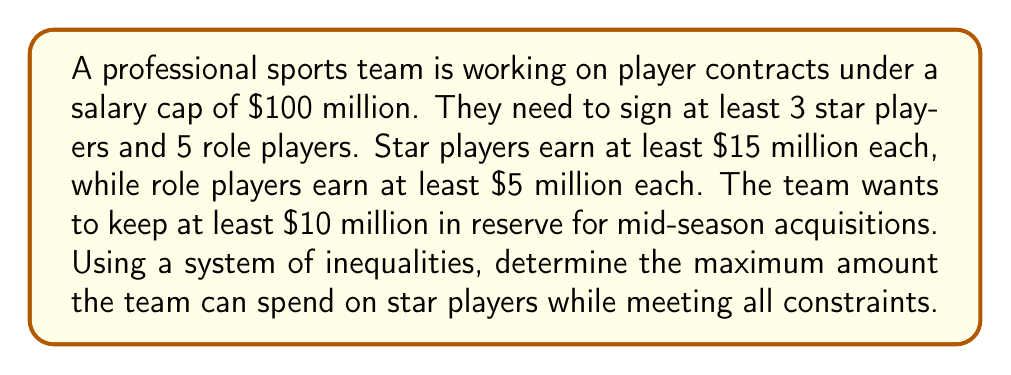Give your solution to this math problem. Let's approach this step-by-step:

1) Define variables:
   $x$ = number of star players
   $y$ = number of role players
   $s$ = amount spent on star players

2) Set up inequalities:
   a) Number of players: $x \geq 3$ and $y \geq 5$
   b) Salary constraints:
      $s \geq 15x$ (star players earn at least $15 million each)
      $5y \leq 100 - s - 10$ (role players' salaries + star players' salaries + reserve ≤ salary cap)

3) Combine inequalities:
   $15x \leq s \leq 90 - 5y$

4) Since we want to maximize $s$, we'll use the minimum values for $x$ and $y$:
   $x = 3$ and $y = 5$

5) Substitute these values:
   $15(3) \leq s \leq 90 - 5(5)$
   $45 \leq s \leq 65$

6) The maximum value for $s$ is 65.

Therefore, the maximum amount the team can spend on star players while meeting all constraints is $65 million.
Answer: $65 million 